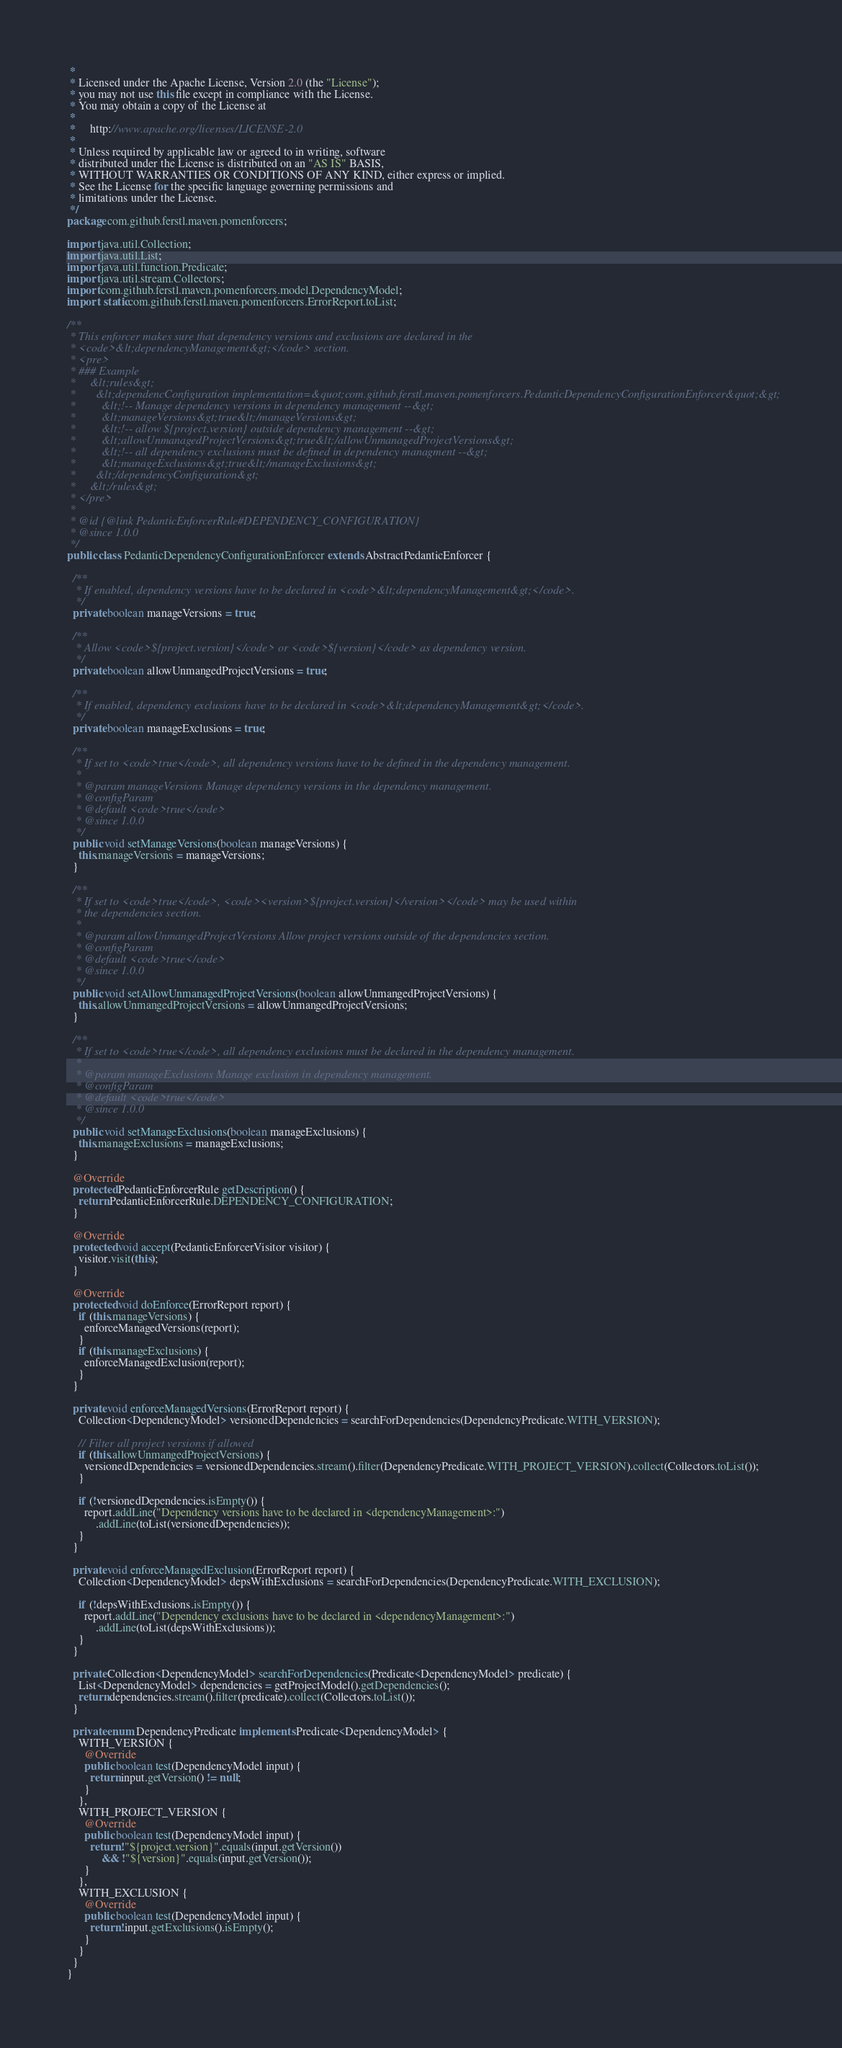<code> <loc_0><loc_0><loc_500><loc_500><_Java_> *
 * Licensed under the Apache License, Version 2.0 (the "License");
 * you may not use this file except in compliance with the License.
 * You may obtain a copy of the License at
 *
 *     http://www.apache.org/licenses/LICENSE-2.0
 *
 * Unless required by applicable law or agreed to in writing, software
 * distributed under the License is distributed on an "AS IS" BASIS,
 * WITHOUT WARRANTIES OR CONDITIONS OF ANY KIND, either express or implied.
 * See the License for the specific language governing permissions and
 * limitations under the License.
 */
package com.github.ferstl.maven.pomenforcers;

import java.util.Collection;
import java.util.List;
import java.util.function.Predicate;
import java.util.stream.Collectors;
import com.github.ferstl.maven.pomenforcers.model.DependencyModel;
import static com.github.ferstl.maven.pomenforcers.ErrorReport.toList;

/**
 * This enforcer makes sure that dependency versions and exclusions are declared in the
 * <code>&lt;dependencyManagement&gt;</code> section.
 * <pre>
 * ### Example
 *     &lt;rules&gt;
 *       &lt;dependencConfiguration implementation=&quot;com.github.ferstl.maven.pomenforcers.PedanticDependencyConfigurationEnforcer&quot;&gt;
 *         &lt;!-- Manage dependency versions in dependency management --&gt;
 *         &lt;manageVersions&gt;true&lt;/manageVersions&gt;
 *         &lt;!-- allow ${project.version} outside dependency management --&gt;
 *         &lt;allowUnmanagedProjectVersions&gt;true&lt;/allowUnmanagedProjectVersions&gt;
 *         &lt;!-- all dependency exclusions must be defined in dependency managment --&gt;
 *         &lt;manageExclusions&gt;true&lt;/manageExclusions&gt;
 *       &lt;/dependencyConfiguration&gt;
 *     &lt;/rules&gt;
 * </pre>
 *
 * @id {@link PedanticEnforcerRule#DEPENDENCY_CONFIGURATION}
 * @since 1.0.0
 */
public class PedanticDependencyConfigurationEnforcer extends AbstractPedanticEnforcer {

  /**
   * If enabled, dependency versions have to be declared in <code>&lt;dependencyManagement&gt;</code>.
   */
  private boolean manageVersions = true;

  /**
   * Allow <code>${project.version}</code> or <code>${version}</code> as dependency version.
   */
  private boolean allowUnmangedProjectVersions = true;

  /**
   * If enabled, dependency exclusions have to be declared in <code>&lt;dependencyManagement&gt;</code>.
   */
  private boolean manageExclusions = true;

  /**
   * If set to <code>true</code>, all dependency versions have to be defined in the dependency management.
   *
   * @param manageVersions Manage dependency versions in the dependency management.
   * @configParam
   * @default <code>true</code>
   * @since 1.0.0
   */
  public void setManageVersions(boolean manageVersions) {
    this.manageVersions = manageVersions;
  }

  /**
   * If set to <code>true</code>, <code><version>${project.version}</version></code> may be used within
   * the dependencies section.
   *
   * @param allowUnmangedProjectVersions Allow project versions outside of the dependencies section.
   * @configParam
   * @default <code>true</code>
   * @since 1.0.0
   */
  public void setAllowUnmanagedProjectVersions(boolean allowUnmangedProjectVersions) {
    this.allowUnmangedProjectVersions = allowUnmangedProjectVersions;
  }

  /**
   * If set to <code>true</code>, all dependency exclusions must be declared in the dependency management.
   *
   * @param manageExclusions Manage exclusion in dependency management.
   * @configParam
   * @default <code>true</code>
   * @since 1.0.0
   */
  public void setManageExclusions(boolean manageExclusions) {
    this.manageExclusions = manageExclusions;
  }

  @Override
  protected PedanticEnforcerRule getDescription() {
    return PedanticEnforcerRule.DEPENDENCY_CONFIGURATION;
  }

  @Override
  protected void accept(PedanticEnforcerVisitor visitor) {
    visitor.visit(this);
  }

  @Override
  protected void doEnforce(ErrorReport report) {
    if (this.manageVersions) {
      enforceManagedVersions(report);
    }
    if (this.manageExclusions) {
      enforceManagedExclusion(report);
    }
  }

  private void enforceManagedVersions(ErrorReport report) {
    Collection<DependencyModel> versionedDependencies = searchForDependencies(DependencyPredicate.WITH_VERSION);

    // Filter all project versions if allowed
    if (this.allowUnmangedProjectVersions) {
      versionedDependencies = versionedDependencies.stream().filter(DependencyPredicate.WITH_PROJECT_VERSION).collect(Collectors.toList());
    }

    if (!versionedDependencies.isEmpty()) {
      report.addLine("Dependency versions have to be declared in <dependencyManagement>:")
          .addLine(toList(versionedDependencies));
    }
  }

  private void enforceManagedExclusion(ErrorReport report) {
    Collection<DependencyModel> depsWithExclusions = searchForDependencies(DependencyPredicate.WITH_EXCLUSION);

    if (!depsWithExclusions.isEmpty()) {
      report.addLine("Dependency exclusions have to be declared in <dependencyManagement>:")
          .addLine(toList(depsWithExclusions));
    }
  }

  private Collection<DependencyModel> searchForDependencies(Predicate<DependencyModel> predicate) {
    List<DependencyModel> dependencies = getProjectModel().getDependencies();
    return dependencies.stream().filter(predicate).collect(Collectors.toList());
  }

  private enum DependencyPredicate implements Predicate<DependencyModel> {
    WITH_VERSION {
      @Override
      public boolean test(DependencyModel input) {
        return input.getVersion() != null;
      }
    },
    WITH_PROJECT_VERSION {
      @Override
      public boolean test(DependencyModel input) {
        return !"${project.version}".equals(input.getVersion())
            && !"${version}".equals(input.getVersion());
      }
    },
    WITH_EXCLUSION {
      @Override
      public boolean test(DependencyModel input) {
        return !input.getExclusions().isEmpty();
      }
    }
  }
}
</code> 